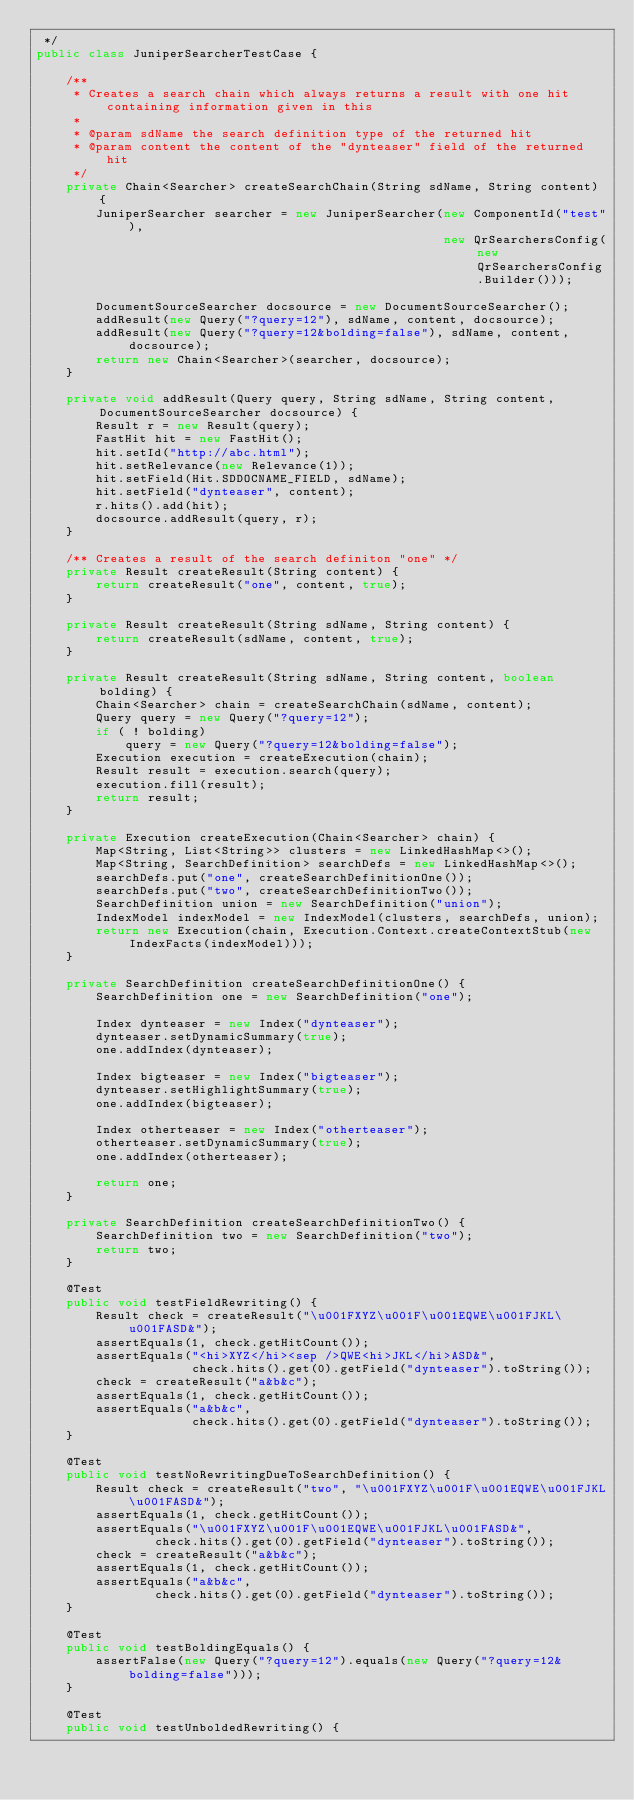<code> <loc_0><loc_0><loc_500><loc_500><_Java_> */
public class JuniperSearcherTestCase {

    /**
     * Creates a search chain which always returns a result with one hit containing information given in this
     *
     * @param sdName the search definition type of the returned hit
     * @param content the content of the "dynteaser" field of the returned hit
     */
    private Chain<Searcher> createSearchChain(String sdName, String content) {
        JuniperSearcher searcher = new JuniperSearcher(new ComponentId("test"),
                                                       new QrSearchersConfig(new QrSearchersConfig.Builder()));

        DocumentSourceSearcher docsource = new DocumentSourceSearcher();
        addResult(new Query("?query=12"), sdName, content, docsource);
        addResult(new Query("?query=12&bolding=false"), sdName, content, docsource);
        return new Chain<Searcher>(searcher, docsource);
    }

    private void addResult(Query query, String sdName, String content, DocumentSourceSearcher docsource) {
        Result r = new Result(query);
        FastHit hit = new FastHit();
        hit.setId("http://abc.html");
        hit.setRelevance(new Relevance(1));
        hit.setField(Hit.SDDOCNAME_FIELD, sdName);
        hit.setField("dynteaser", content);
        r.hits().add(hit);
        docsource.addResult(query, r);
    }

    /** Creates a result of the search definiton "one" */
    private Result createResult(String content) {
        return createResult("one", content, true);
    }

    private Result createResult(String sdName, String content) {
        return createResult(sdName, content, true);
    }

    private Result createResult(String sdName, String content, boolean bolding) {
        Chain<Searcher> chain = createSearchChain(sdName, content);
        Query query = new Query("?query=12");
        if ( ! bolding)
            query = new Query("?query=12&bolding=false");
        Execution execution = createExecution(chain);
        Result result = execution.search(query);
        execution.fill(result);
        return result;
    }

    private Execution createExecution(Chain<Searcher> chain) {
        Map<String, List<String>> clusters = new LinkedHashMap<>();
        Map<String, SearchDefinition> searchDefs = new LinkedHashMap<>();
        searchDefs.put("one", createSearchDefinitionOne());
        searchDefs.put("two", createSearchDefinitionTwo());
        SearchDefinition union = new SearchDefinition("union");
        IndexModel indexModel = new IndexModel(clusters, searchDefs, union);
        return new Execution(chain, Execution.Context.createContextStub(new IndexFacts(indexModel)));
    }

    private SearchDefinition createSearchDefinitionOne() {
        SearchDefinition one = new SearchDefinition("one");

        Index dynteaser = new Index("dynteaser");
        dynteaser.setDynamicSummary(true);
        one.addIndex(dynteaser);

        Index bigteaser = new Index("bigteaser");
        dynteaser.setHighlightSummary(true);
        one.addIndex(bigteaser);

        Index otherteaser = new Index("otherteaser");
        otherteaser.setDynamicSummary(true);
        one.addIndex(otherteaser);

        return one;
    }

    private SearchDefinition createSearchDefinitionTwo() {
        SearchDefinition two = new SearchDefinition("two");
        return two;
    }

    @Test
    public void testFieldRewriting() {
        Result check = createResult("\u001FXYZ\u001F\u001EQWE\u001FJKL\u001FASD&");
        assertEquals(1, check.getHitCount());
        assertEquals("<hi>XYZ</hi><sep />QWE<hi>JKL</hi>ASD&",
                     check.hits().get(0).getField("dynteaser").toString());
        check = createResult("a&b&c");
        assertEquals(1, check.getHitCount());
        assertEquals("a&b&c",
                     check.hits().get(0).getField("dynteaser").toString());
    }

    @Test
    public void testNoRewritingDueToSearchDefinition() {
        Result check = createResult("two", "\u001FXYZ\u001F\u001EQWE\u001FJKL\u001FASD&");
        assertEquals(1, check.getHitCount());
        assertEquals("\u001FXYZ\u001F\u001EQWE\u001FJKL\u001FASD&",
                check.hits().get(0).getField("dynteaser").toString());
        check = createResult("a&b&c");
        assertEquals(1, check.getHitCount());
        assertEquals("a&b&c",
                check.hits().get(0).getField("dynteaser").toString());
    }

    @Test
    public void testBoldingEquals() {
        assertFalse(new Query("?query=12").equals(new Query("?query=12&bolding=false")));
    }

    @Test
    public void testUnboldedRewriting() {</code> 